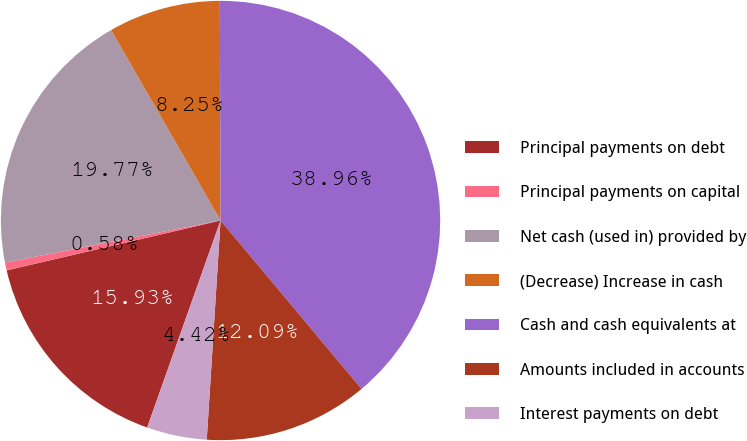<chart> <loc_0><loc_0><loc_500><loc_500><pie_chart><fcel>Principal payments on debt<fcel>Principal payments on capital<fcel>Net cash (used in) provided by<fcel>(Decrease) Increase in cash<fcel>Cash and cash equivalents at<fcel>Amounts included in accounts<fcel>Interest payments on debt<nl><fcel>15.93%<fcel>0.58%<fcel>19.77%<fcel>8.25%<fcel>38.96%<fcel>12.09%<fcel>4.42%<nl></chart> 